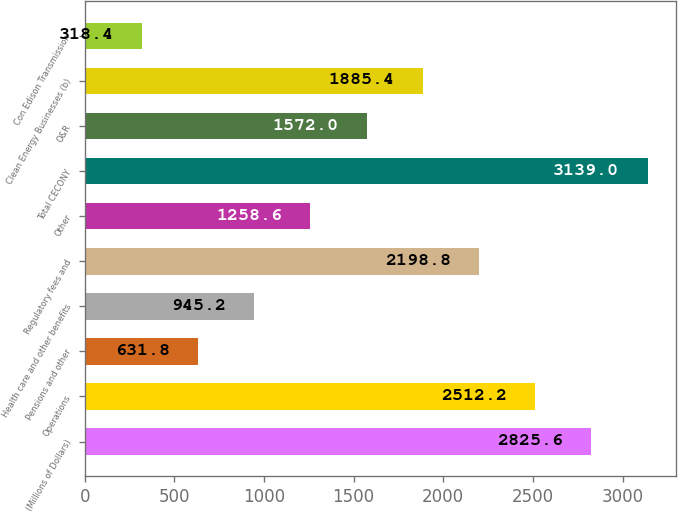Convert chart. <chart><loc_0><loc_0><loc_500><loc_500><bar_chart><fcel>(Millions of Dollars)<fcel>Operations<fcel>Pensions and other<fcel>Health care and other benefits<fcel>Regulatory fees and<fcel>Other<fcel>Total CECONY<fcel>O&R<fcel>Clean Energy Businesses (b)<fcel>Con Edison Transmission<nl><fcel>2825.6<fcel>2512.2<fcel>631.8<fcel>945.2<fcel>2198.8<fcel>1258.6<fcel>3139<fcel>1572<fcel>1885.4<fcel>318.4<nl></chart> 